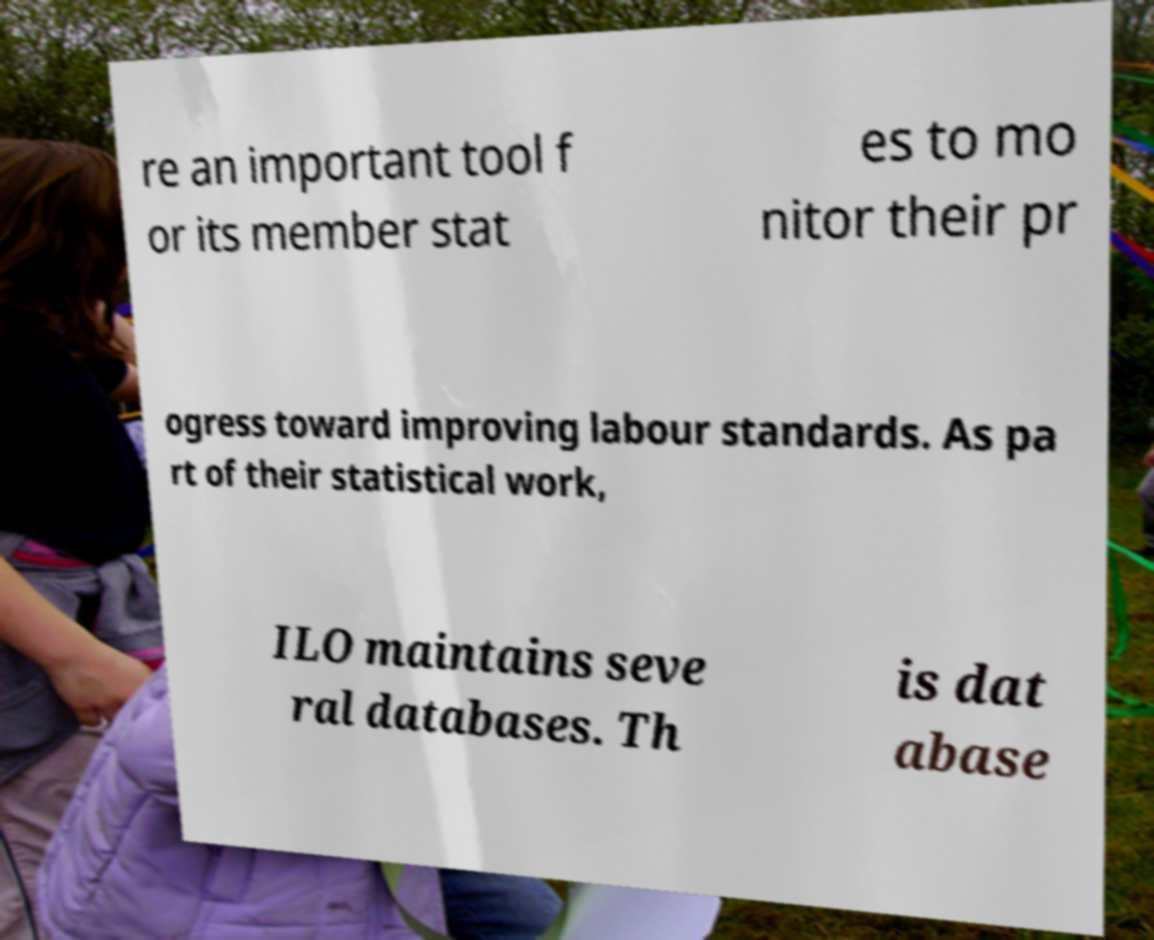There's text embedded in this image that I need extracted. Can you transcribe it verbatim? re an important tool f or its member stat es to mo nitor their pr ogress toward improving labour standards. As pa rt of their statistical work, ILO maintains seve ral databases. Th is dat abase 